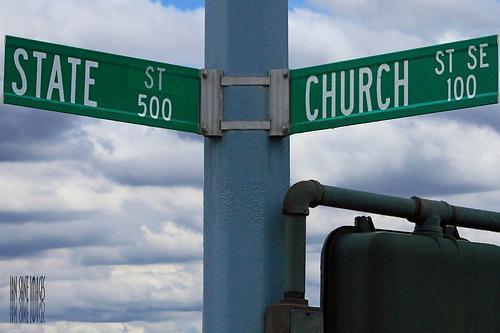How many signs are there?
Give a very brief answer. 2. 